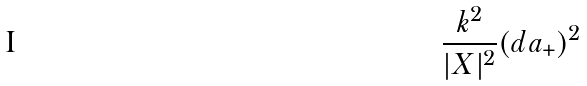<formula> <loc_0><loc_0><loc_500><loc_500>\frac { k ^ { 2 } } { | X | ^ { 2 } } ( d a _ { + } ) ^ { 2 }</formula> 